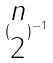<formula> <loc_0><loc_0><loc_500><loc_500>( \begin{matrix} n \\ 2 \end{matrix} ) ^ { - 1 }</formula> 